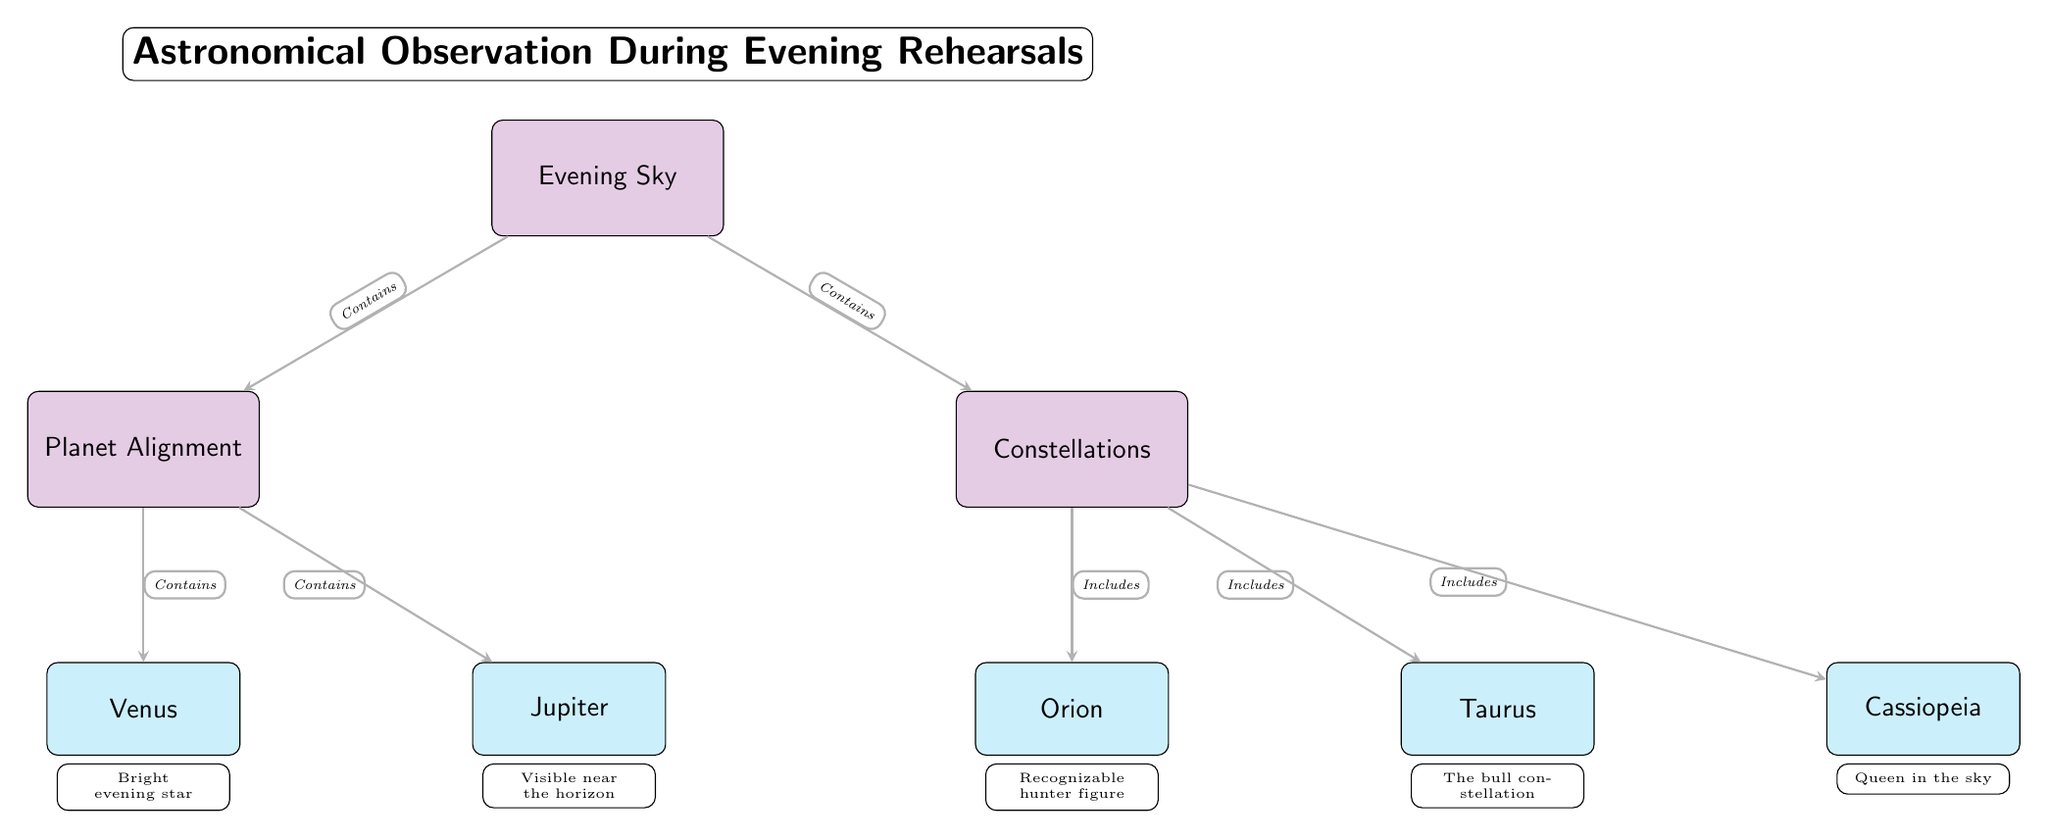What is at the top of the diagram? The top of the diagram contains the title "Astronomical Observation During Evening Rehearsals," indicating the main subject of the illustration.
Answer: Astronomical Observation During Evening Rehearsals How many planets are represented in the diagram? The diagram shows two sub nodes under the 'Planet Alignment' node, which are Venus and Jupiter. Thus, there are two planets represented.
Answer: 2 What constellation is included in the diagram that represents a hunter? The node under the 'Constellations' labeled Orion refers to the recognizable hunter figure.
Answer: Orion Which planet is described as a bright evening star? Under 'Planet Alignment,' Venus is described as a "Bright evening star" in the background notes.
Answer: Venus What is the relationship between the 'Evening Sky' and 'Planet Alignment'? The diagram has an edge indicating that 'Evening Sky' contains 'Planet Alignment,' signifying that planet alignment is part of the evening sky observation.
Answer: Contains Which constellation is referred to as the 'Queen in the sky'? The node labeled Cassiopeia under 'Constellations' is noted to represent the 'Queen in the sky.'
Answer: Cassiopeia Name the two constellations included in the diagram besides Orion. The other constellations listed include Taurus and Cassiopeia in the diagram.
Answer: Taurus, Cassiopeia Which planet is noted to be visible near the horizon? The diagram's background note for Jupiter states that it is "Visible near the horizon."
Answer: Jupiter What information is provided about Taurus in the diagram? The note under Taurus states it is "The bull constellation," providing a brief description of the constellation.
Answer: The bull constellation 